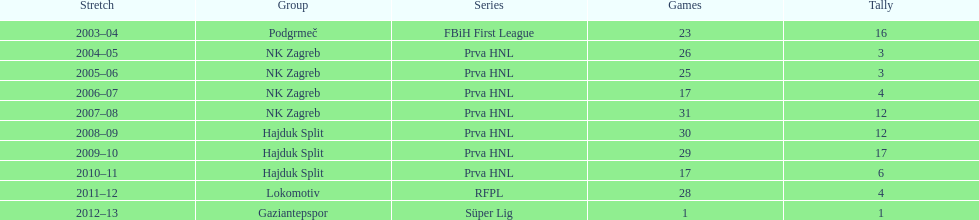Help me parse the entirety of this table. {'header': ['Stretch', 'Group', 'Series', 'Games', 'Tally'], 'rows': [['2003–04', 'Podgrmeč', 'FBiH First League', '23', '16'], ['2004–05', 'NK Zagreb', 'Prva HNL', '26', '3'], ['2005–06', 'NK Zagreb', 'Prva HNL', '25', '3'], ['2006–07', 'NK Zagreb', 'Prva HNL', '17', '4'], ['2007–08', 'NK Zagreb', 'Prva HNL', '31', '12'], ['2008–09', 'Hajduk Split', 'Prva HNL', '30', '12'], ['2009–10', 'Hajduk Split', 'Prva HNL', '29', '17'], ['2010–11', 'Hajduk Split', 'Prva HNL', '17', '6'], ['2011–12', 'Lokomotiv', 'RFPL', '28', '4'], ['2012–13', 'Gaziantepspor', 'Süper Lig', '1', '1']]} What were the names of each club where more than 15 goals were scored in a single season? Podgrmeč, Hajduk Split. 